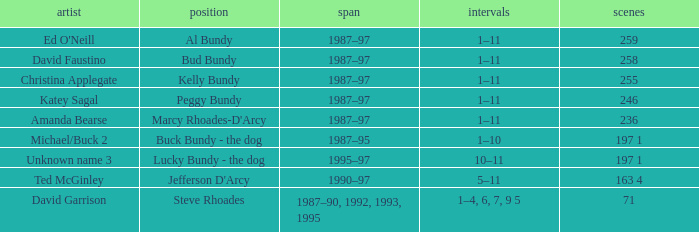Can you parse all the data within this table? {'header': ['artist', 'position', 'span', 'intervals', 'scenes'], 'rows': [["Ed O'Neill", 'Al Bundy', '1987–97', '1–11', '259'], ['David Faustino', 'Bud Bundy', '1987–97', '1–11', '258'], ['Christina Applegate', 'Kelly Bundy', '1987–97', '1–11', '255'], ['Katey Sagal', 'Peggy Bundy', '1987–97', '1–11', '246'], ['Amanda Bearse', "Marcy Rhoades-D'Arcy", '1987–97', '1–11', '236'], ['Michael/Buck 2', 'Buck Bundy - the dog', '1987–95', '1–10', '197 1'], ['Unknown name 3', 'Lucky Bundy - the dog', '1995–97', '10–11', '197 1'], ['Ted McGinley', "Jefferson D'Arcy", '1990–97', '5–11', '163 4'], ['David Garrison', 'Steve Rhoades', '1987–90, 1992, 1993, 1995', '1–4, 6, 7, 9 5', '71']]} How many episodes did the actor David Faustino appear in? 258.0. 